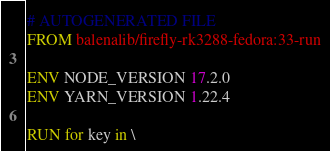<code> <loc_0><loc_0><loc_500><loc_500><_Dockerfile_># AUTOGENERATED FILE
FROM balenalib/firefly-rk3288-fedora:33-run

ENV NODE_VERSION 17.2.0
ENV YARN_VERSION 1.22.4

RUN for key in \</code> 